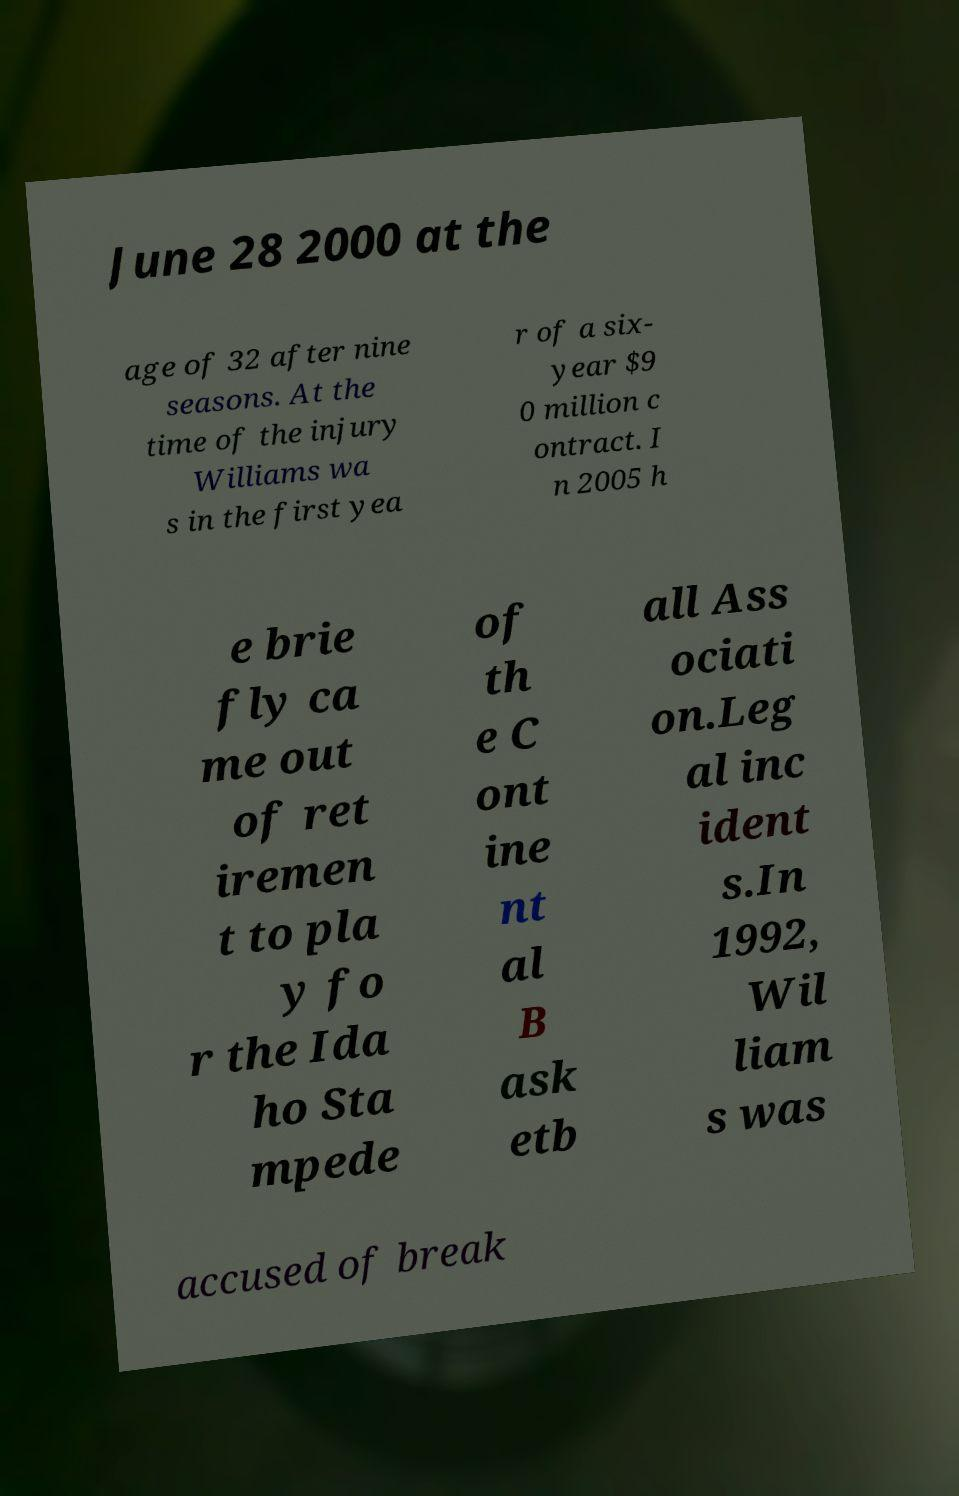Please identify and transcribe the text found in this image. June 28 2000 at the age of 32 after nine seasons. At the time of the injury Williams wa s in the first yea r of a six- year $9 0 million c ontract. I n 2005 h e brie fly ca me out of ret iremen t to pla y fo r the Ida ho Sta mpede of th e C ont ine nt al B ask etb all Ass ociati on.Leg al inc ident s.In 1992, Wil liam s was accused of break 